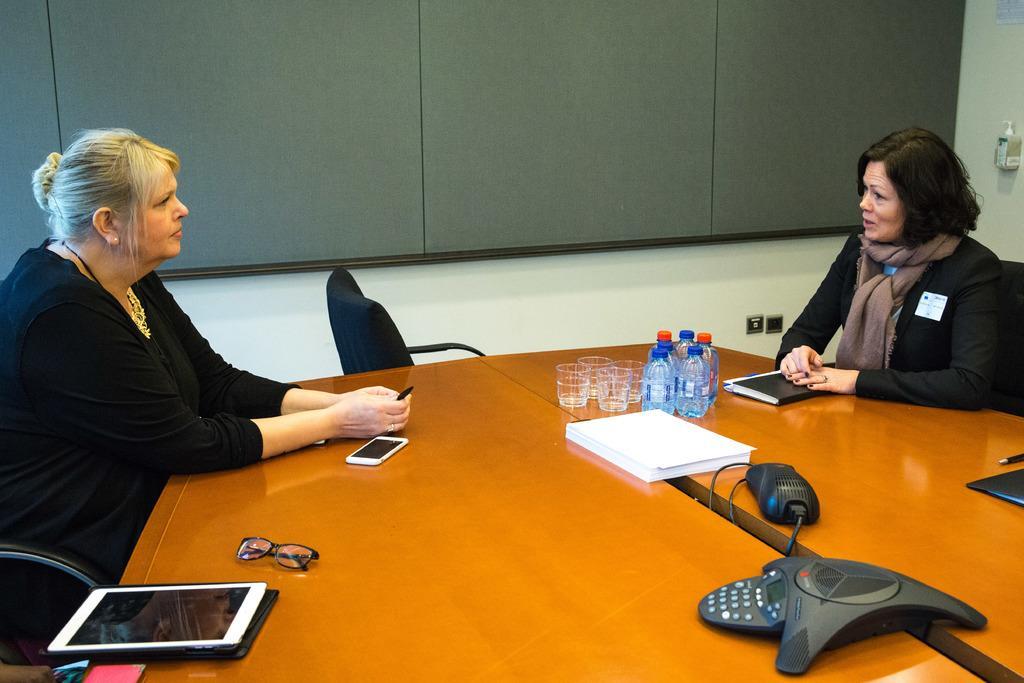In one or two sentences, can you explain what this image depicts? In this image I can see two people are sitting on the chairs. I can see few bottles, glasses, few objects on the brown table. Back I can see the grey color window-blind and the white color wall. 